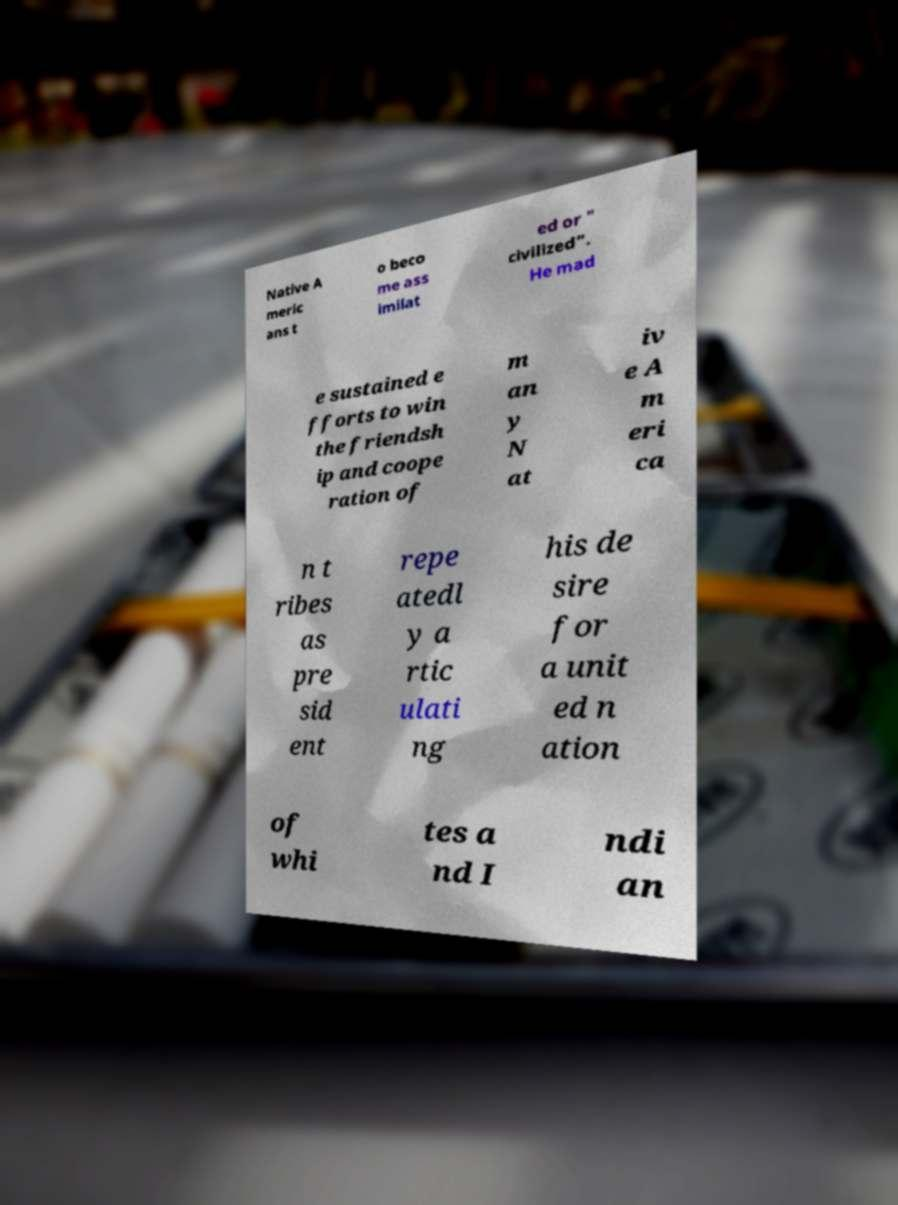Could you assist in decoding the text presented in this image and type it out clearly? Native A meric ans t o beco me ass imilat ed or " civilized". He mad e sustained e fforts to win the friendsh ip and coope ration of m an y N at iv e A m eri ca n t ribes as pre sid ent repe atedl y a rtic ulati ng his de sire for a unit ed n ation of whi tes a nd I ndi an 